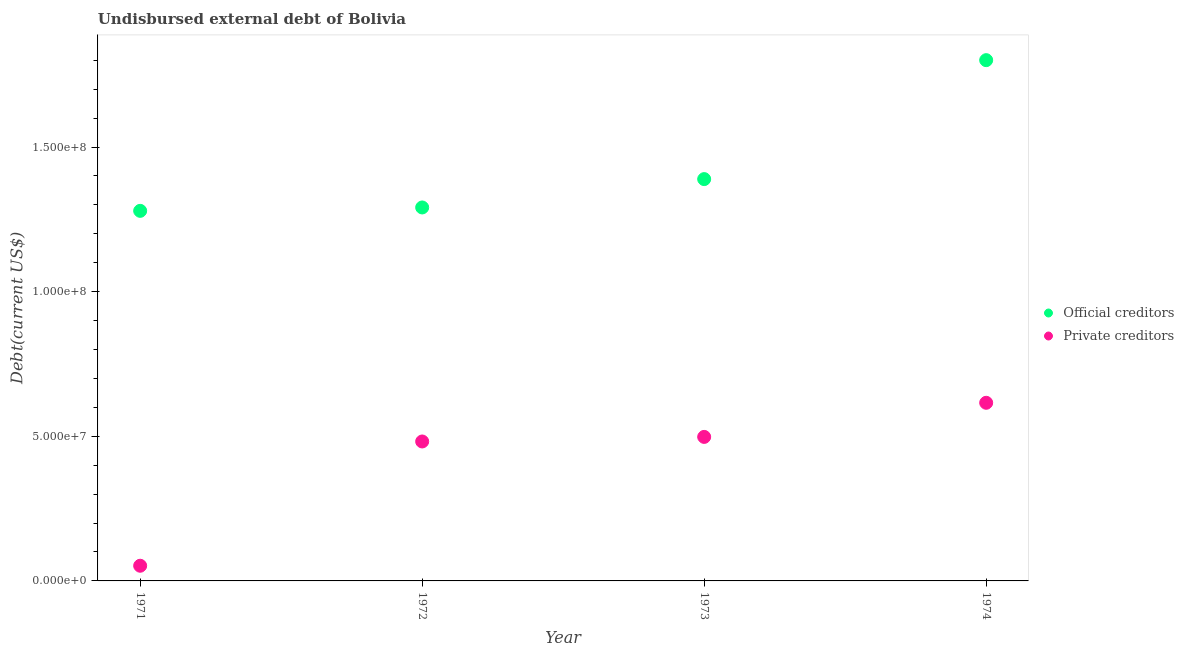Is the number of dotlines equal to the number of legend labels?
Your response must be concise. Yes. What is the undisbursed external debt of official creditors in 1971?
Your answer should be very brief. 1.28e+08. Across all years, what is the maximum undisbursed external debt of private creditors?
Offer a terse response. 6.16e+07. Across all years, what is the minimum undisbursed external debt of official creditors?
Your answer should be compact. 1.28e+08. In which year was the undisbursed external debt of private creditors maximum?
Your answer should be compact. 1974. What is the total undisbursed external debt of private creditors in the graph?
Your answer should be very brief. 1.65e+08. What is the difference between the undisbursed external debt of official creditors in 1973 and that in 1974?
Provide a short and direct response. -4.11e+07. What is the difference between the undisbursed external debt of private creditors in 1972 and the undisbursed external debt of official creditors in 1971?
Offer a very short reply. -7.97e+07. What is the average undisbursed external debt of private creditors per year?
Give a very brief answer. 4.12e+07. In the year 1972, what is the difference between the undisbursed external debt of official creditors and undisbursed external debt of private creditors?
Provide a short and direct response. 8.09e+07. What is the ratio of the undisbursed external debt of private creditors in 1971 to that in 1973?
Provide a succinct answer. 0.11. Is the undisbursed external debt of private creditors in 1972 less than that in 1973?
Offer a very short reply. Yes. Is the difference between the undisbursed external debt of private creditors in 1973 and 1974 greater than the difference between the undisbursed external debt of official creditors in 1973 and 1974?
Keep it short and to the point. Yes. What is the difference between the highest and the second highest undisbursed external debt of official creditors?
Your response must be concise. 4.11e+07. What is the difference between the highest and the lowest undisbursed external debt of official creditors?
Your response must be concise. 5.21e+07. In how many years, is the undisbursed external debt of official creditors greater than the average undisbursed external debt of official creditors taken over all years?
Provide a succinct answer. 1. Is the sum of the undisbursed external debt of official creditors in 1971 and 1973 greater than the maximum undisbursed external debt of private creditors across all years?
Provide a short and direct response. Yes. Does the undisbursed external debt of official creditors monotonically increase over the years?
Give a very brief answer. Yes. Is the undisbursed external debt of official creditors strictly greater than the undisbursed external debt of private creditors over the years?
Provide a short and direct response. Yes. Is the undisbursed external debt of private creditors strictly less than the undisbursed external debt of official creditors over the years?
Your answer should be compact. Yes. How many dotlines are there?
Ensure brevity in your answer.  2. What is the difference between two consecutive major ticks on the Y-axis?
Offer a terse response. 5.00e+07. Does the graph contain any zero values?
Your response must be concise. No. How many legend labels are there?
Offer a very short reply. 2. What is the title of the graph?
Ensure brevity in your answer.  Undisbursed external debt of Bolivia. Does "Long-term debt" appear as one of the legend labels in the graph?
Provide a short and direct response. No. What is the label or title of the Y-axis?
Give a very brief answer. Debt(current US$). What is the Debt(current US$) in Official creditors in 1971?
Your answer should be compact. 1.28e+08. What is the Debt(current US$) in Private creditors in 1971?
Ensure brevity in your answer.  5.25e+06. What is the Debt(current US$) in Official creditors in 1972?
Keep it short and to the point. 1.29e+08. What is the Debt(current US$) of Private creditors in 1972?
Make the answer very short. 4.82e+07. What is the Debt(current US$) of Official creditors in 1973?
Keep it short and to the point. 1.39e+08. What is the Debt(current US$) in Private creditors in 1973?
Give a very brief answer. 4.98e+07. What is the Debt(current US$) of Official creditors in 1974?
Your answer should be compact. 1.80e+08. What is the Debt(current US$) in Private creditors in 1974?
Your answer should be compact. 6.16e+07. Across all years, what is the maximum Debt(current US$) in Official creditors?
Provide a succinct answer. 1.80e+08. Across all years, what is the maximum Debt(current US$) of Private creditors?
Your answer should be compact. 6.16e+07. Across all years, what is the minimum Debt(current US$) of Official creditors?
Your response must be concise. 1.28e+08. Across all years, what is the minimum Debt(current US$) of Private creditors?
Ensure brevity in your answer.  5.25e+06. What is the total Debt(current US$) of Official creditors in the graph?
Provide a succinct answer. 5.76e+08. What is the total Debt(current US$) of Private creditors in the graph?
Make the answer very short. 1.65e+08. What is the difference between the Debt(current US$) in Official creditors in 1971 and that in 1972?
Offer a terse response. -1.17e+06. What is the difference between the Debt(current US$) in Private creditors in 1971 and that in 1972?
Your response must be concise. -4.30e+07. What is the difference between the Debt(current US$) of Official creditors in 1971 and that in 1973?
Your response must be concise. -1.10e+07. What is the difference between the Debt(current US$) of Private creditors in 1971 and that in 1973?
Your answer should be compact. -4.45e+07. What is the difference between the Debt(current US$) of Official creditors in 1971 and that in 1974?
Provide a succinct answer. -5.21e+07. What is the difference between the Debt(current US$) in Private creditors in 1971 and that in 1974?
Your response must be concise. -5.63e+07. What is the difference between the Debt(current US$) of Official creditors in 1972 and that in 1973?
Give a very brief answer. -9.80e+06. What is the difference between the Debt(current US$) in Private creditors in 1972 and that in 1973?
Provide a short and direct response. -1.58e+06. What is the difference between the Debt(current US$) of Official creditors in 1972 and that in 1974?
Offer a very short reply. -5.09e+07. What is the difference between the Debt(current US$) in Private creditors in 1972 and that in 1974?
Offer a terse response. -1.34e+07. What is the difference between the Debt(current US$) of Official creditors in 1973 and that in 1974?
Offer a terse response. -4.11e+07. What is the difference between the Debt(current US$) of Private creditors in 1973 and that in 1974?
Your response must be concise. -1.18e+07. What is the difference between the Debt(current US$) in Official creditors in 1971 and the Debt(current US$) in Private creditors in 1972?
Offer a terse response. 7.97e+07. What is the difference between the Debt(current US$) in Official creditors in 1971 and the Debt(current US$) in Private creditors in 1973?
Provide a succinct answer. 7.82e+07. What is the difference between the Debt(current US$) in Official creditors in 1971 and the Debt(current US$) in Private creditors in 1974?
Your answer should be very brief. 6.64e+07. What is the difference between the Debt(current US$) of Official creditors in 1972 and the Debt(current US$) of Private creditors in 1973?
Your response must be concise. 7.93e+07. What is the difference between the Debt(current US$) of Official creditors in 1972 and the Debt(current US$) of Private creditors in 1974?
Provide a short and direct response. 6.75e+07. What is the difference between the Debt(current US$) in Official creditors in 1973 and the Debt(current US$) in Private creditors in 1974?
Make the answer very short. 7.73e+07. What is the average Debt(current US$) in Official creditors per year?
Your response must be concise. 1.44e+08. What is the average Debt(current US$) in Private creditors per year?
Give a very brief answer. 4.12e+07. In the year 1971, what is the difference between the Debt(current US$) in Official creditors and Debt(current US$) in Private creditors?
Offer a very short reply. 1.23e+08. In the year 1972, what is the difference between the Debt(current US$) of Official creditors and Debt(current US$) of Private creditors?
Offer a very short reply. 8.09e+07. In the year 1973, what is the difference between the Debt(current US$) of Official creditors and Debt(current US$) of Private creditors?
Your response must be concise. 8.91e+07. In the year 1974, what is the difference between the Debt(current US$) of Official creditors and Debt(current US$) of Private creditors?
Give a very brief answer. 1.18e+08. What is the ratio of the Debt(current US$) in Official creditors in 1971 to that in 1972?
Offer a very short reply. 0.99. What is the ratio of the Debt(current US$) of Private creditors in 1971 to that in 1972?
Provide a succinct answer. 0.11. What is the ratio of the Debt(current US$) in Official creditors in 1971 to that in 1973?
Your response must be concise. 0.92. What is the ratio of the Debt(current US$) of Private creditors in 1971 to that in 1973?
Provide a succinct answer. 0.11. What is the ratio of the Debt(current US$) of Official creditors in 1971 to that in 1974?
Give a very brief answer. 0.71. What is the ratio of the Debt(current US$) in Private creditors in 1971 to that in 1974?
Provide a short and direct response. 0.09. What is the ratio of the Debt(current US$) in Official creditors in 1972 to that in 1973?
Your answer should be compact. 0.93. What is the ratio of the Debt(current US$) of Private creditors in 1972 to that in 1973?
Give a very brief answer. 0.97. What is the ratio of the Debt(current US$) of Official creditors in 1972 to that in 1974?
Offer a very short reply. 0.72. What is the ratio of the Debt(current US$) of Private creditors in 1972 to that in 1974?
Ensure brevity in your answer.  0.78. What is the ratio of the Debt(current US$) in Official creditors in 1973 to that in 1974?
Ensure brevity in your answer.  0.77. What is the ratio of the Debt(current US$) in Private creditors in 1973 to that in 1974?
Provide a succinct answer. 0.81. What is the difference between the highest and the second highest Debt(current US$) of Official creditors?
Offer a very short reply. 4.11e+07. What is the difference between the highest and the second highest Debt(current US$) in Private creditors?
Ensure brevity in your answer.  1.18e+07. What is the difference between the highest and the lowest Debt(current US$) of Official creditors?
Your answer should be compact. 5.21e+07. What is the difference between the highest and the lowest Debt(current US$) in Private creditors?
Keep it short and to the point. 5.63e+07. 